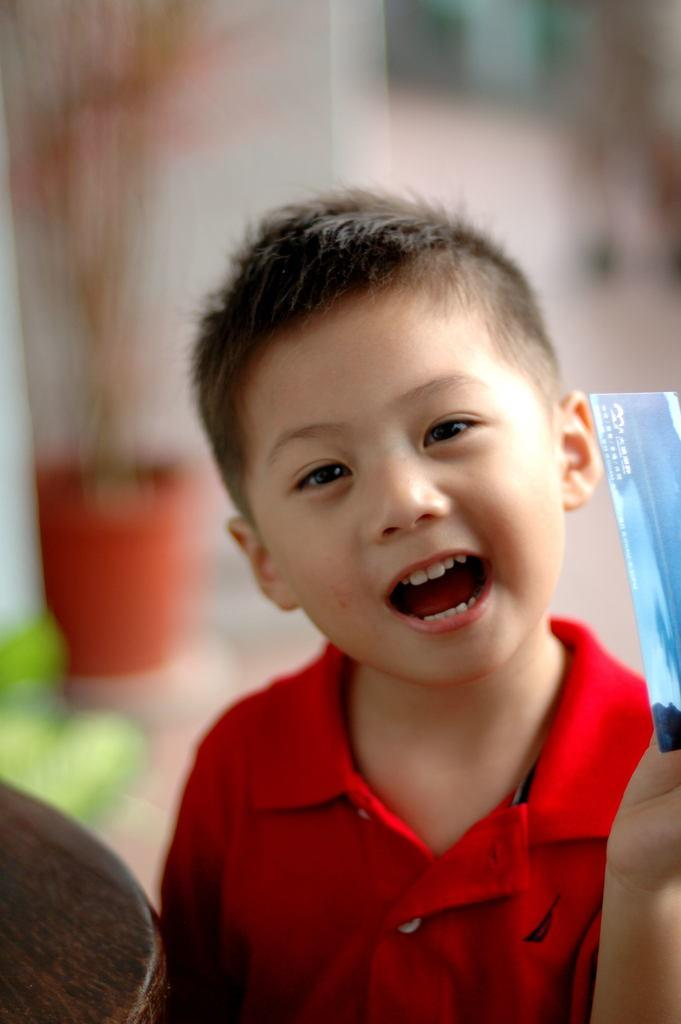Who is present in the image? There is a boy in the image. What is the boy doing in the image? The boy is smiling in the image. What is the boy holding in the image? The boy is holding an object in the image. What type of plant can be seen in the image? There is a house plant visible in the image. How would you describe the background of the image? The background of the image is blurred. What type of cannon can be seen in the image? There is no cannon present in the image. How does the boy react to the shock in the image? The boy is smiling in the image, not reacting to any shock. 